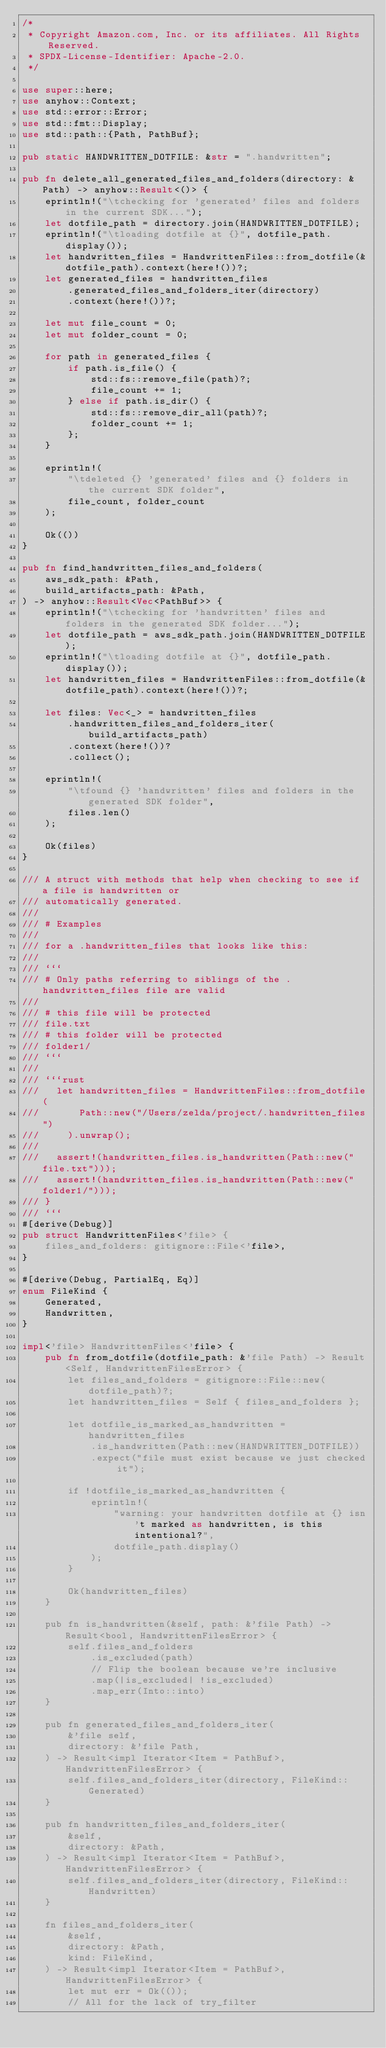Convert code to text. <code><loc_0><loc_0><loc_500><loc_500><_Rust_>/*
 * Copyright Amazon.com, Inc. or its affiliates. All Rights Reserved.
 * SPDX-License-Identifier: Apache-2.0.
 */

use super::here;
use anyhow::Context;
use std::error::Error;
use std::fmt::Display;
use std::path::{Path, PathBuf};

pub static HANDWRITTEN_DOTFILE: &str = ".handwritten";

pub fn delete_all_generated_files_and_folders(directory: &Path) -> anyhow::Result<()> {
    eprintln!("\tchecking for 'generated' files and folders in the current SDK...");
    let dotfile_path = directory.join(HANDWRITTEN_DOTFILE);
    eprintln!("\tloading dotfile at {}", dotfile_path.display());
    let handwritten_files = HandwrittenFiles::from_dotfile(&dotfile_path).context(here!())?;
    let generated_files = handwritten_files
        .generated_files_and_folders_iter(directory)
        .context(here!())?;

    let mut file_count = 0;
    let mut folder_count = 0;

    for path in generated_files {
        if path.is_file() {
            std::fs::remove_file(path)?;
            file_count += 1;
        } else if path.is_dir() {
            std::fs::remove_dir_all(path)?;
            folder_count += 1;
        };
    }

    eprintln!(
        "\tdeleted {} 'generated' files and {} folders in the current SDK folder",
        file_count, folder_count
    );

    Ok(())
}

pub fn find_handwritten_files_and_folders(
    aws_sdk_path: &Path,
    build_artifacts_path: &Path,
) -> anyhow::Result<Vec<PathBuf>> {
    eprintln!("\tchecking for 'handwritten' files and folders in the generated SDK folder...");
    let dotfile_path = aws_sdk_path.join(HANDWRITTEN_DOTFILE);
    eprintln!("\tloading dotfile at {}", dotfile_path.display());
    let handwritten_files = HandwrittenFiles::from_dotfile(&dotfile_path).context(here!())?;

    let files: Vec<_> = handwritten_files
        .handwritten_files_and_folders_iter(build_artifacts_path)
        .context(here!())?
        .collect();

    eprintln!(
        "\tfound {} 'handwritten' files and folders in the generated SDK folder",
        files.len()
    );

    Ok(files)
}

/// A struct with methods that help when checking to see if a file is handwritten or
/// automatically generated.
///
/// # Examples
///
/// for a .handwritten_files that looks like this:
///
/// ```
/// # Only paths referring to siblings of the .handwritten_files file are valid
///
/// # this file will be protected
/// file.txt
/// # this folder will be protected
/// folder1/
/// ```
///
/// ```rust
///   let handwritten_files = HandwrittenFiles::from_dotfile(
///       Path::new("/Users/zelda/project/.handwritten_files")
///     ).unwrap();
///
///   assert!(handwritten_files.is_handwritten(Path::new("file.txt")));
///   assert!(handwritten_files.is_handwritten(Path::new("folder1/")));
/// }
/// ```
#[derive(Debug)]
pub struct HandwrittenFiles<'file> {
    files_and_folders: gitignore::File<'file>,
}

#[derive(Debug, PartialEq, Eq)]
enum FileKind {
    Generated,
    Handwritten,
}

impl<'file> HandwrittenFiles<'file> {
    pub fn from_dotfile(dotfile_path: &'file Path) -> Result<Self, HandwrittenFilesError> {
        let files_and_folders = gitignore::File::new(dotfile_path)?;
        let handwritten_files = Self { files_and_folders };

        let dotfile_is_marked_as_handwritten = handwritten_files
            .is_handwritten(Path::new(HANDWRITTEN_DOTFILE))
            .expect("file must exist because we just checked it");

        if !dotfile_is_marked_as_handwritten {
            eprintln!(
                "warning: your handwritten dotfile at {} isn't marked as handwritten, is this intentional?",
                dotfile_path.display()
            );
        }

        Ok(handwritten_files)
    }

    pub fn is_handwritten(&self, path: &'file Path) -> Result<bool, HandwrittenFilesError> {
        self.files_and_folders
            .is_excluded(path)
            // Flip the boolean because we're inclusive
            .map(|is_excluded| !is_excluded)
            .map_err(Into::into)
    }

    pub fn generated_files_and_folders_iter(
        &'file self,
        directory: &'file Path,
    ) -> Result<impl Iterator<Item = PathBuf>, HandwrittenFilesError> {
        self.files_and_folders_iter(directory, FileKind::Generated)
    }

    pub fn handwritten_files_and_folders_iter(
        &self,
        directory: &Path,
    ) -> Result<impl Iterator<Item = PathBuf>, HandwrittenFilesError> {
        self.files_and_folders_iter(directory, FileKind::Handwritten)
    }

    fn files_and_folders_iter(
        &self,
        directory: &Path,
        kind: FileKind,
    ) -> Result<impl Iterator<Item = PathBuf>, HandwrittenFilesError> {
        let mut err = Ok(());
        // All for the lack of try_filter</code> 